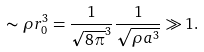<formula> <loc_0><loc_0><loc_500><loc_500>\sim \rho r _ { 0 } ^ { 3 } = \frac { 1 } { \sqrt { 8 \pi } ^ { 3 } } \frac { 1 } { \sqrt { \rho a ^ { 3 } } } \gg 1 .</formula> 